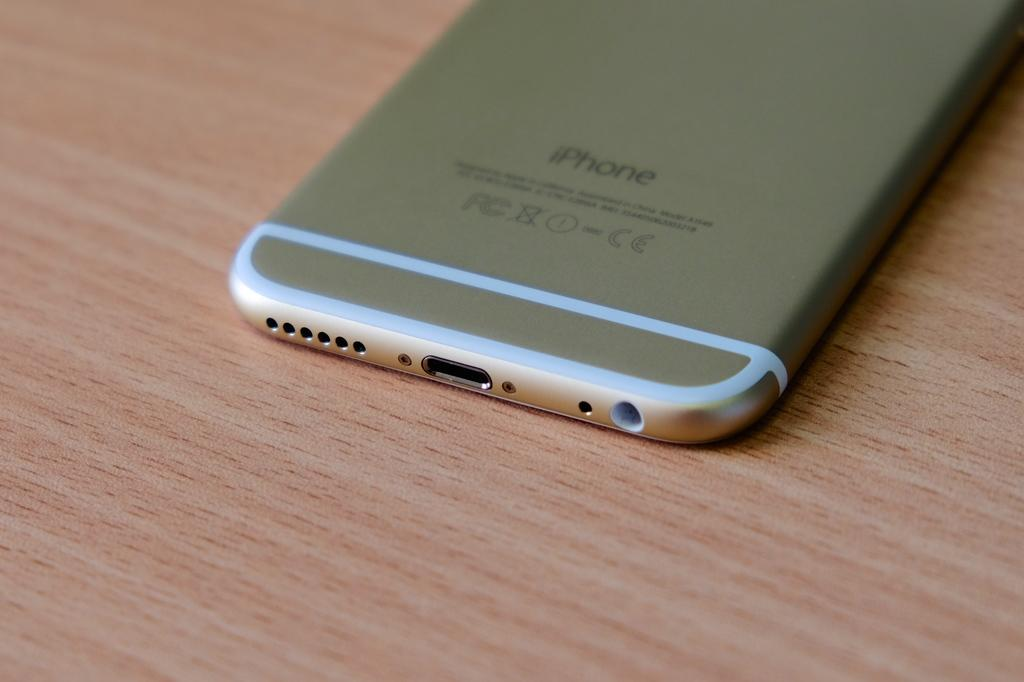Provide a one-sentence caption for the provided image. a gold iphone sits on an empty wooden desk. 